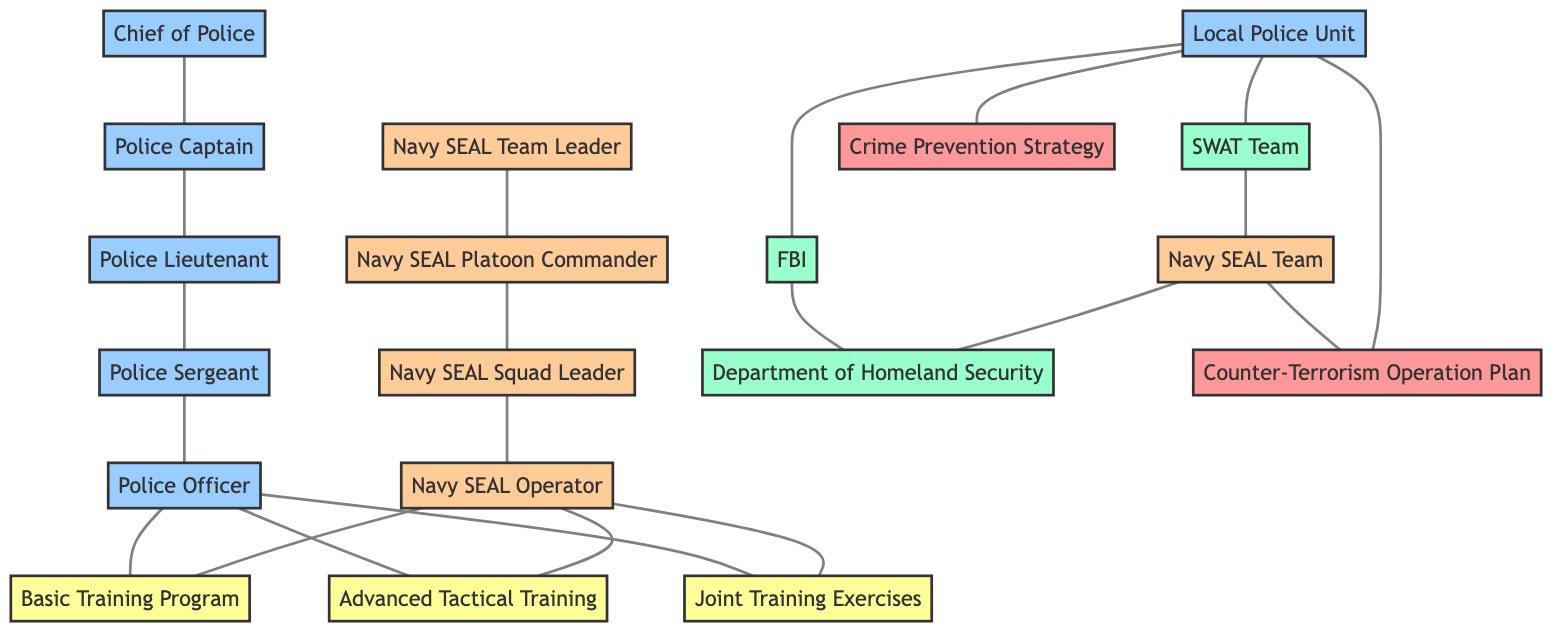What is the highest rank within the police unit depicted in the diagram? The diagram shows a chain of supervision starting from the Chief of Police at the top of the police hierarchy, indicating that this rank is the highest within the police unit.
Answer: Chief of Police How many training programs are represented in the diagram? The diagram lists three training programs: Basic Training Program, Advanced Tactical Training, and Joint Training Exercises. By counting these segments in the training section, we determine there are three distinct programs.
Answer: 3 Which department communicates with both the Local Police Unit and the Department of Homeland Security? By examining the communication links, the FBI is shown to communicate with both the Local Police Unit and the Department of Homeland Security (DHS). Thus, it serves as a connection point between these two entities.
Answer: FBI What is the relationship between the Navy SEAL Team and the Department of Homeland Security? The diagram shows a direct connection where the Navy SEAL Team communicates with the Department of Homeland Security. This means there is a communication flow between these two entities, indicating a collaborative effort or information exchange.
Answer: communicates with Which unit coordinates with the SWAT Team? The diagram specifies a connection where the Local Police Unit is shown to coordinate with the SWAT Team, thereby indicating their working relationship in dealing with emergency situations or law enforcement.
Answer: Local Police Unit What two entities participate in Joint Training Exercises? The diagram indicates that both Police Officers and Navy SEAL Operators participate in Joint Training Exercises, demonstrating collaboration in training between these two groups.
Answer: Police Officer and Navy SEAL Operator Who is responsible for executing the Counter-Terrorism Operation Plan? According to the diagram, the Navy SEAL Team is specifically outlined as the entity responsible for executing the Counter-Terrorism Operation Plan, highlighting their role in such operations.
Answer: Navy SEAL Team How many levels of supervisory rank exist within the local police hierarchy? By analyzing the local police structure, we can see that there are four supervisory ranks: Chief of Police, Police Captain, Police Lieutenant, and Police Sergeant. Each of these ranks supervises the next lower rank down to the Police Officer.
Answer: 4 What is the common training program for both Police Officers and Navy SEAL Operators? Both groups undergo Basic Training Program as indicated in the diagram, which signifies a shared foundational training element between the two different units.
Answer: Basic Training Program 